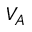Convert formula to latex. <formula><loc_0><loc_0><loc_500><loc_500>V _ { A }</formula> 